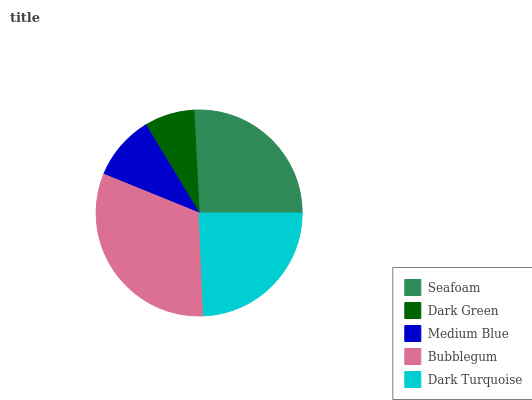Is Dark Green the minimum?
Answer yes or no. Yes. Is Bubblegum the maximum?
Answer yes or no. Yes. Is Medium Blue the minimum?
Answer yes or no. No. Is Medium Blue the maximum?
Answer yes or no. No. Is Medium Blue greater than Dark Green?
Answer yes or no. Yes. Is Dark Green less than Medium Blue?
Answer yes or no. Yes. Is Dark Green greater than Medium Blue?
Answer yes or no. No. Is Medium Blue less than Dark Green?
Answer yes or no. No. Is Dark Turquoise the high median?
Answer yes or no. Yes. Is Dark Turquoise the low median?
Answer yes or no. Yes. Is Dark Green the high median?
Answer yes or no. No. Is Bubblegum the low median?
Answer yes or no. No. 